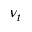<formula> <loc_0><loc_0><loc_500><loc_500>\nu _ { t }</formula> 